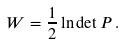Convert formula to latex. <formula><loc_0><loc_0><loc_500><loc_500>W = \frac { 1 } { 2 } \ln \det P \, .</formula> 